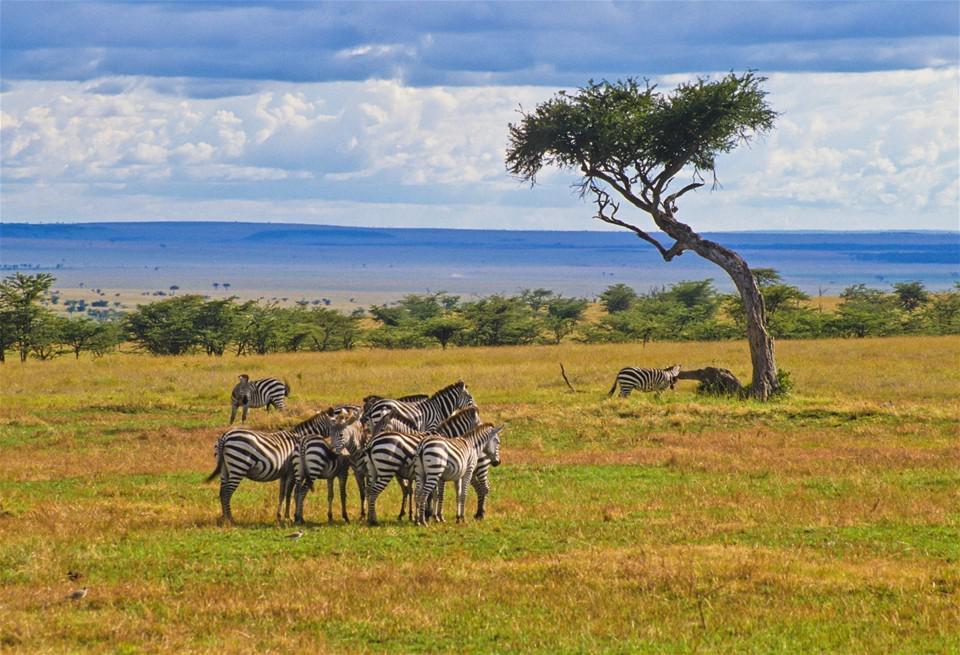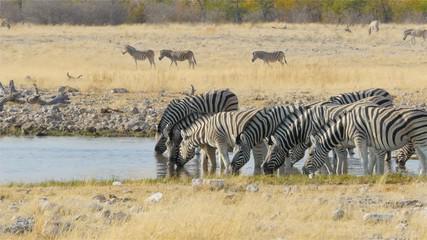The first image is the image on the left, the second image is the image on the right. Given the left and right images, does the statement "There are trees visible in both images." hold true? Answer yes or no. Yes. 